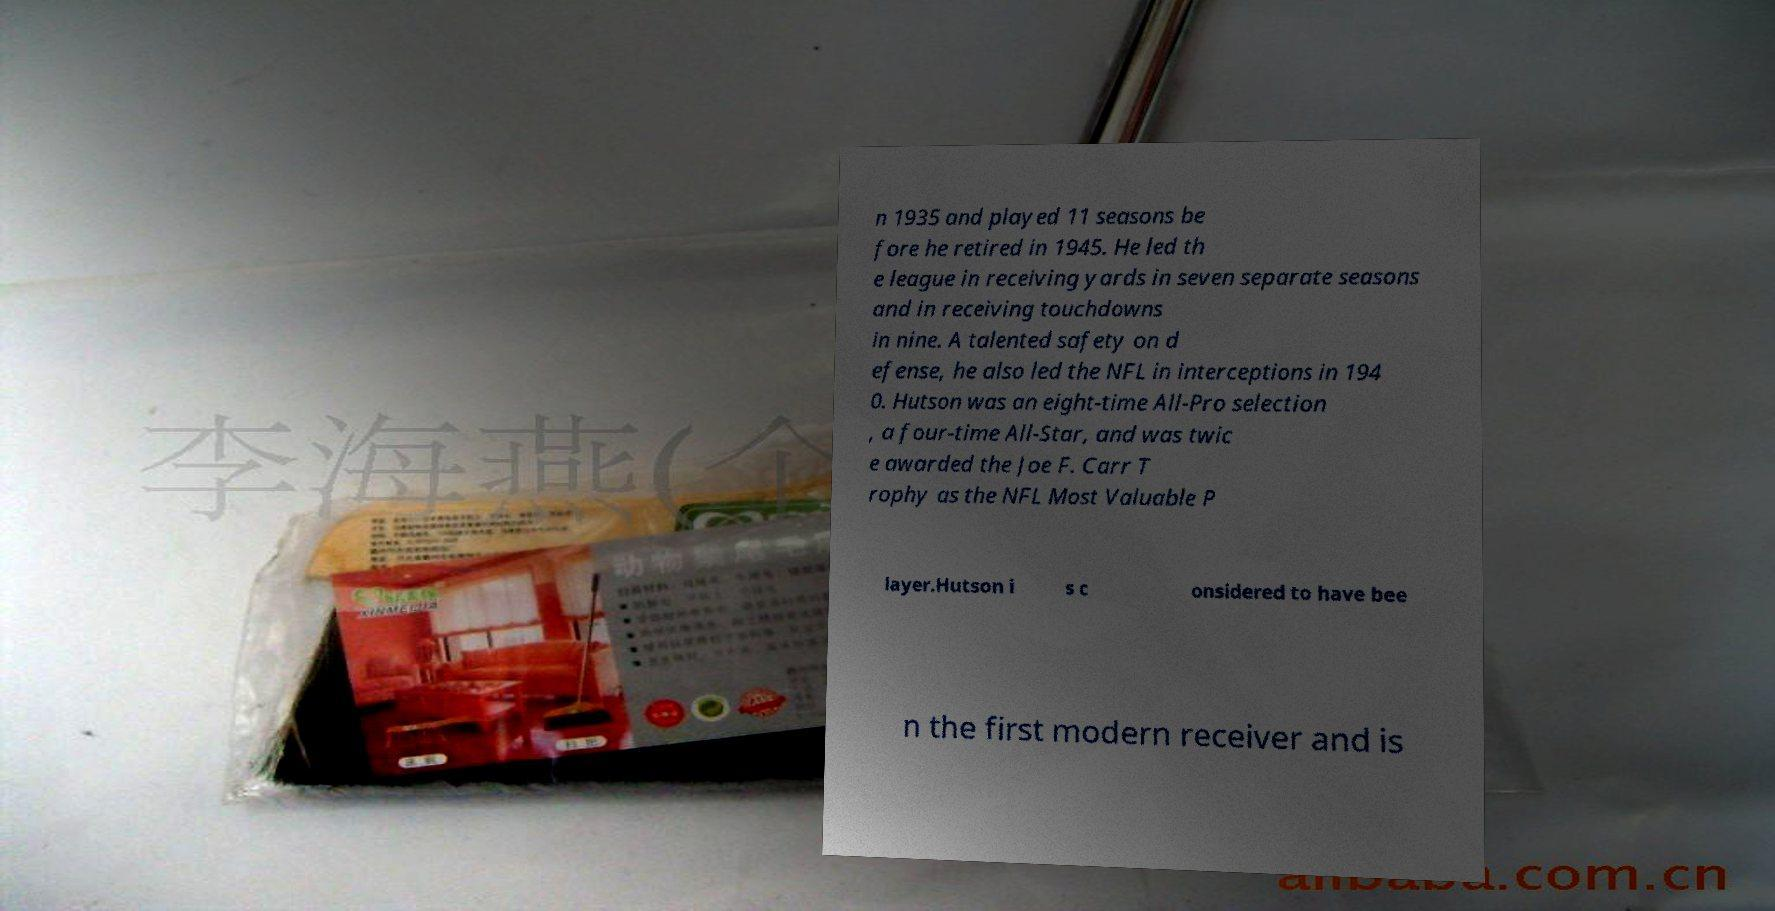Please read and relay the text visible in this image. What does it say? n 1935 and played 11 seasons be fore he retired in 1945. He led th e league in receiving yards in seven separate seasons and in receiving touchdowns in nine. A talented safety on d efense, he also led the NFL in interceptions in 194 0. Hutson was an eight-time All-Pro selection , a four-time All-Star, and was twic e awarded the Joe F. Carr T rophy as the NFL Most Valuable P layer.Hutson i s c onsidered to have bee n the first modern receiver and is 